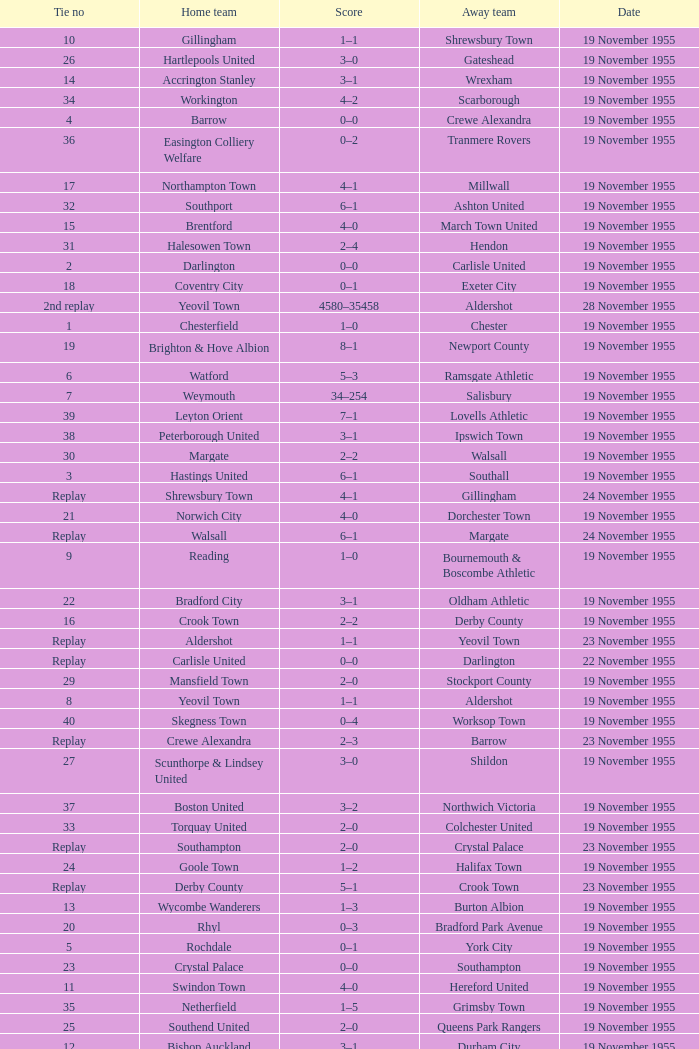What is the away team with a 5 tie no? York City. 